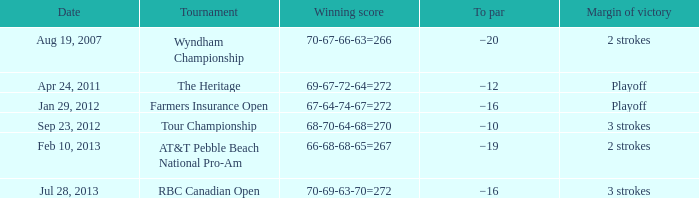What tournament was on Jan 29, 2012? Farmers Insurance Open. 